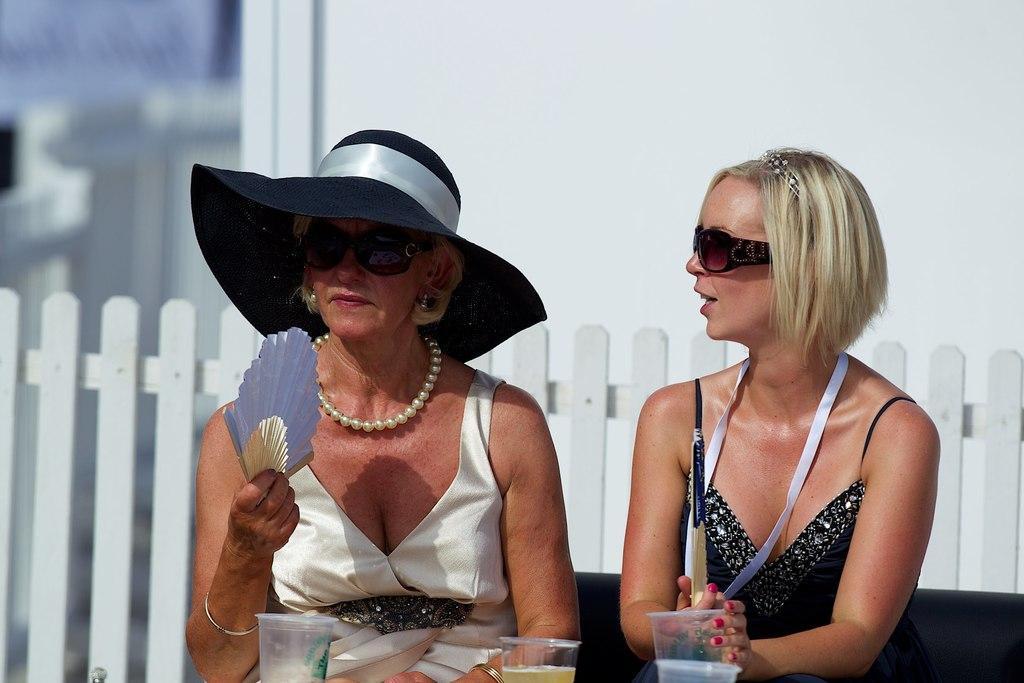How would you summarize this image in a sentence or two? In this image, two people sitting on the sofa and are wearing goggles and holding some objects and one of them is wearing a hat. In the background, there is a fence and and a wall. At the bottom, there are glasses with drinks. 